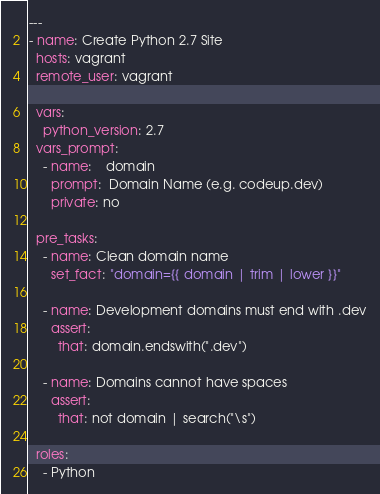Convert code to text. <code><loc_0><loc_0><loc_500><loc_500><_YAML_>---
- name: Create Python 2.7 Site
  hosts: vagrant
  remote_user: vagrant

  vars:
    python_version: 2.7
  vars_prompt:
    - name:    domain
      prompt:  Domain Name (e.g. codeup.dev)
      private: no

  pre_tasks:
    - name: Clean domain name
      set_fact: "domain={{ domain | trim | lower }}"

    - name: Development domains must end with .dev
      assert:
        that: domain.endswith(".dev")

    - name: Domains cannot have spaces
      assert:
        that: not domain | search("\s")

  roles:
    - Python
</code> 